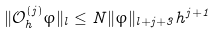Convert formula to latex. <formula><loc_0><loc_0><loc_500><loc_500>\| \mathcal { O } ^ { ( j ) } _ { h } \varphi \| _ { l } \leq N \| \varphi \| _ { l + j + 3 } h ^ { j + 1 }</formula> 